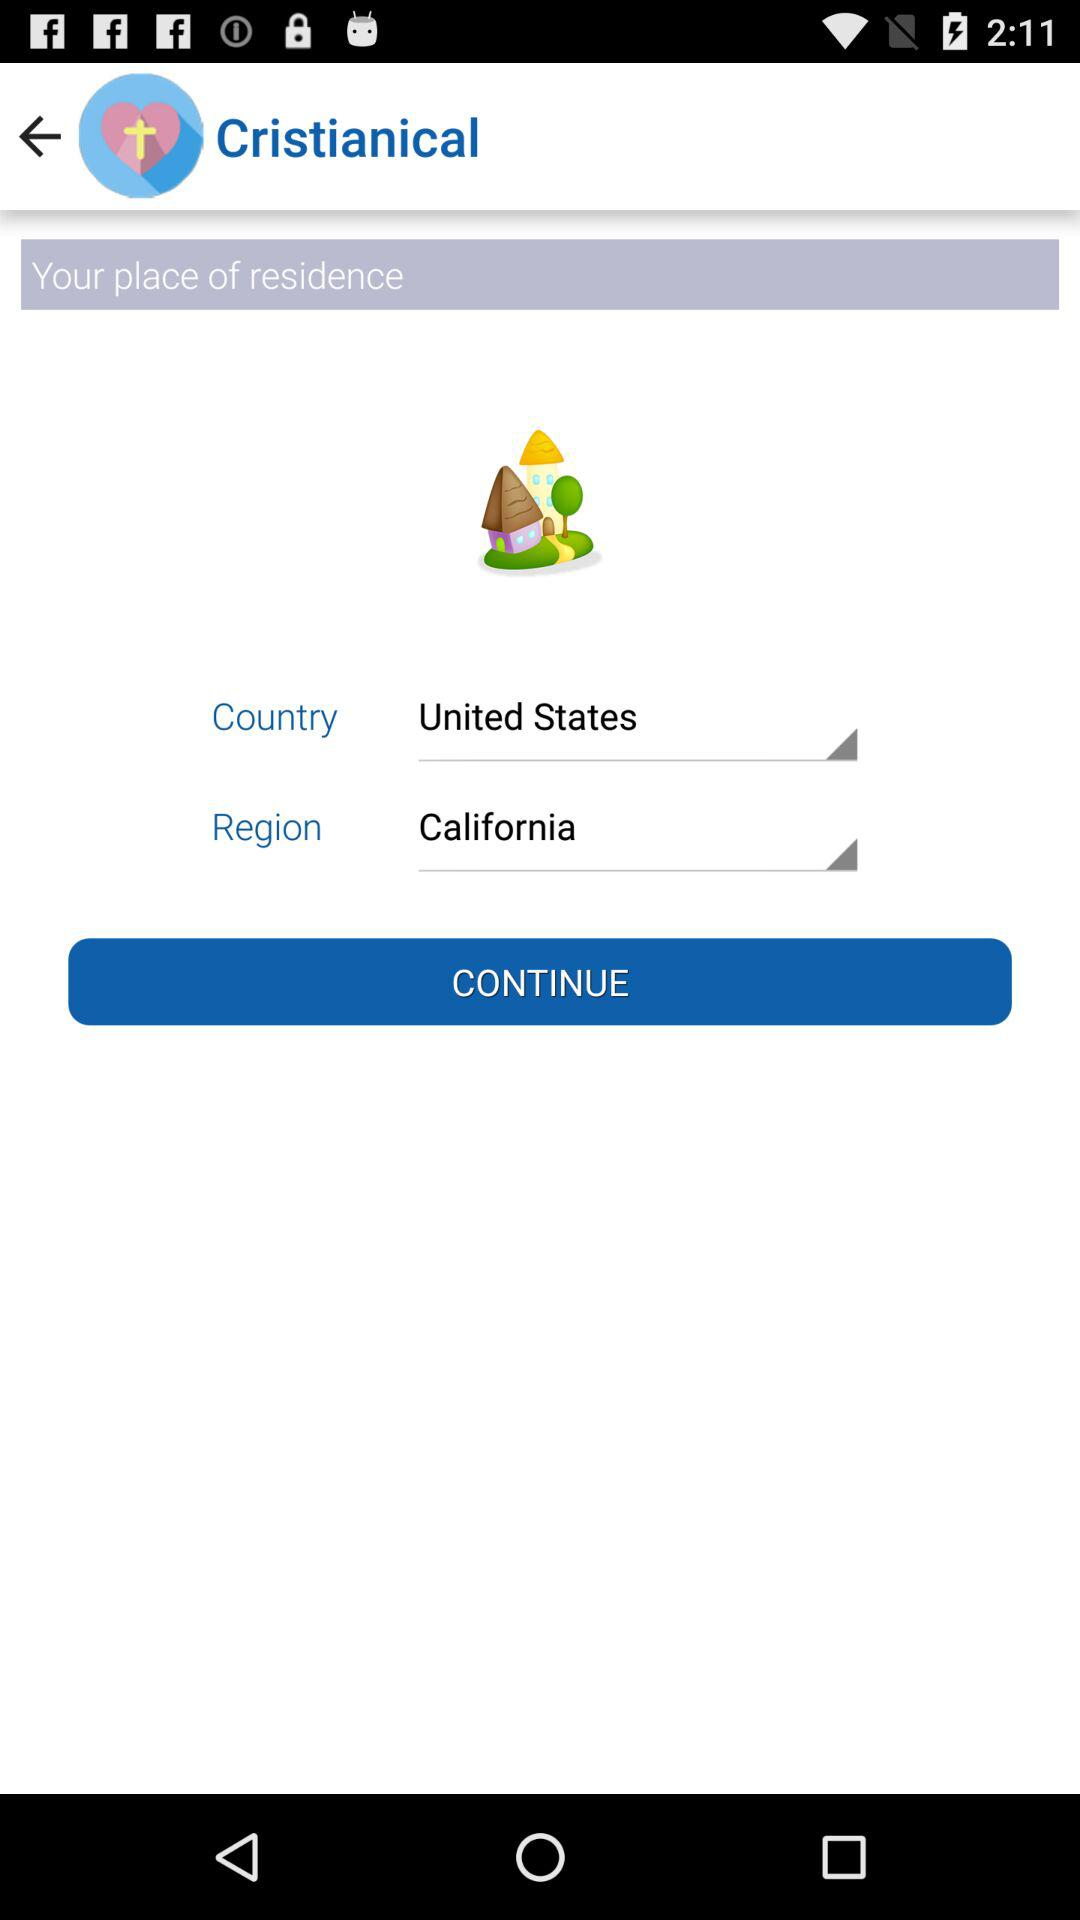What is the selected country? The selected country is the United States. 